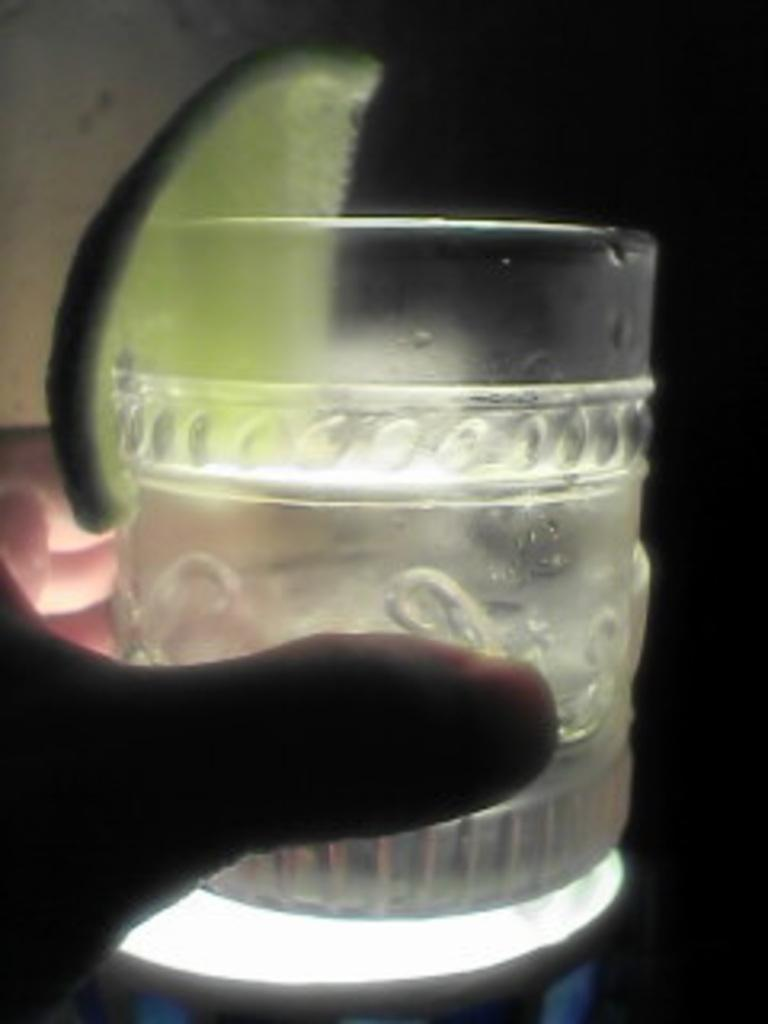What body part is visible in the image? Human fingers are visible in the image. What object is near the fingers? There is a glass in the image. What is inside the glass? A lemon slice is present in the image. How would you describe the overall lighting in the image? The background of the image is dark, but there is a light visible in the image. Can you see a stream of water flowing in the image? There is no stream of water visible in the image. 